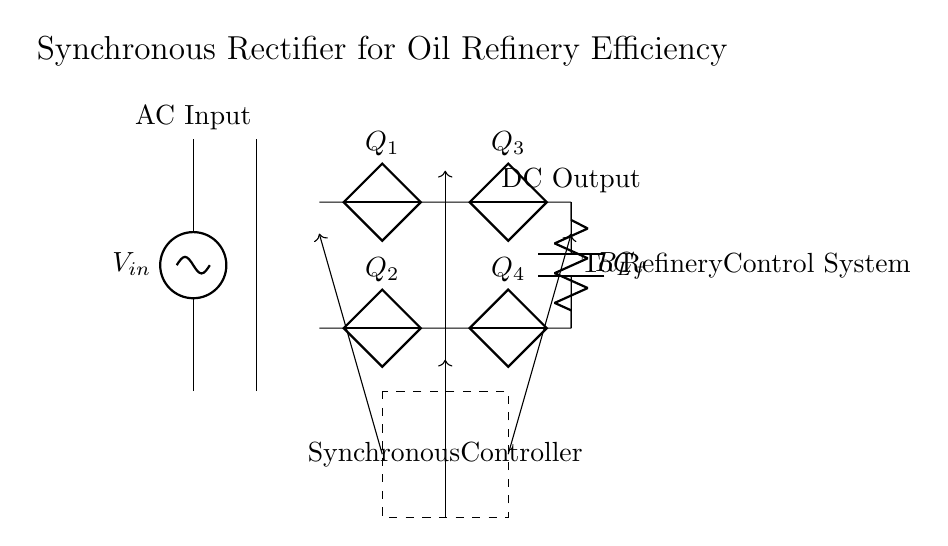What is the type of input voltage in this circuit? The circuit shows an AC source, which is indicated by the label at the input as "AC Input." This defines the nature of the voltage applied to the circuit.
Answer: AC How many diodes are present in the rectifier bridge? The rectifier bridge consists of four labeled components, Q1, Q2, Q3, and Q4, which represent the four diodes used to convert AC to DC.
Answer: Four What is the role of the synchronous controller? The synchronous controller, marked within the dashed rectangle, manages the operation of the diodes based on the input AC, improving efficiency by switching the diodes in sync with the AC input.
Answer: Improve efficiency What is the output type of this circuit? The output is labeled as "DC Output," indicating that the circuit's function is to convert AC input to direct current, which is essential for powering devices.
Answer: DC Where does the output of this rectifier circuit go? The output labeled "To Refinery Control System" indicates the specific application of the DC output, showing it connects directly to the control systems used in oil refining operations.
Answer: Refinery control system What type of capacitor is used in this circuit? The capacitor is labeled as C_f and is typically used for filtering purposes, smoothing the output voltage to reduce ripples and provide stable DC.
Answer: Filtering capacitor 